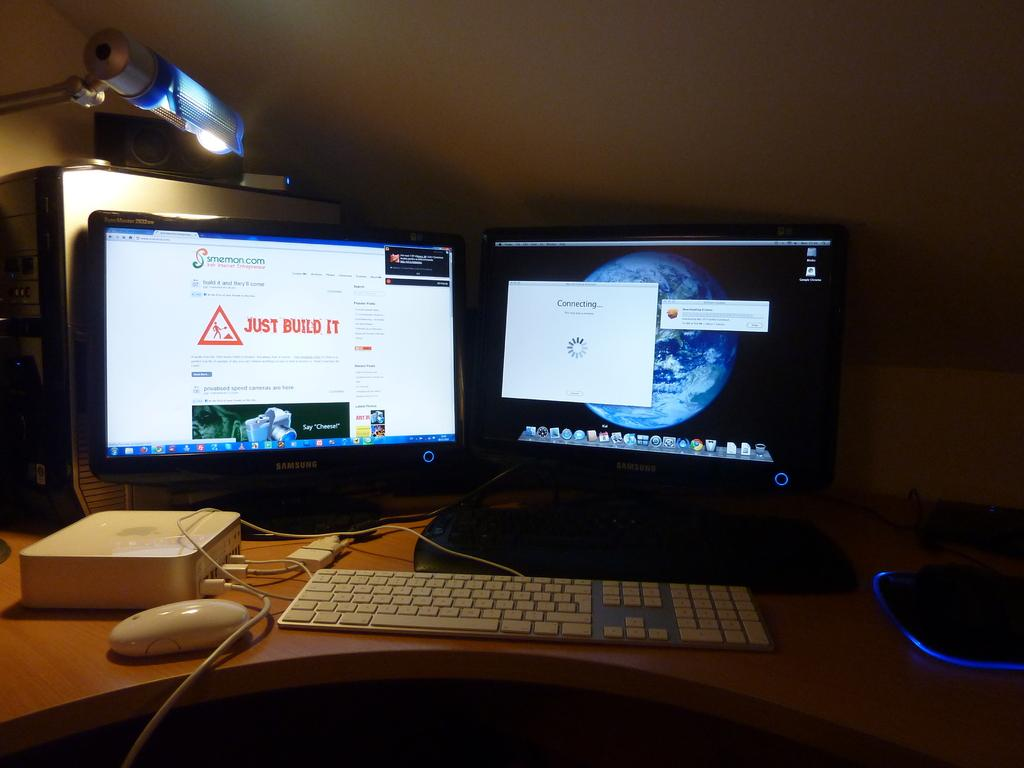Provide a one-sentence caption for the provided image. Two computer screens are shown on a desk, the one on the right is trying to connect. 